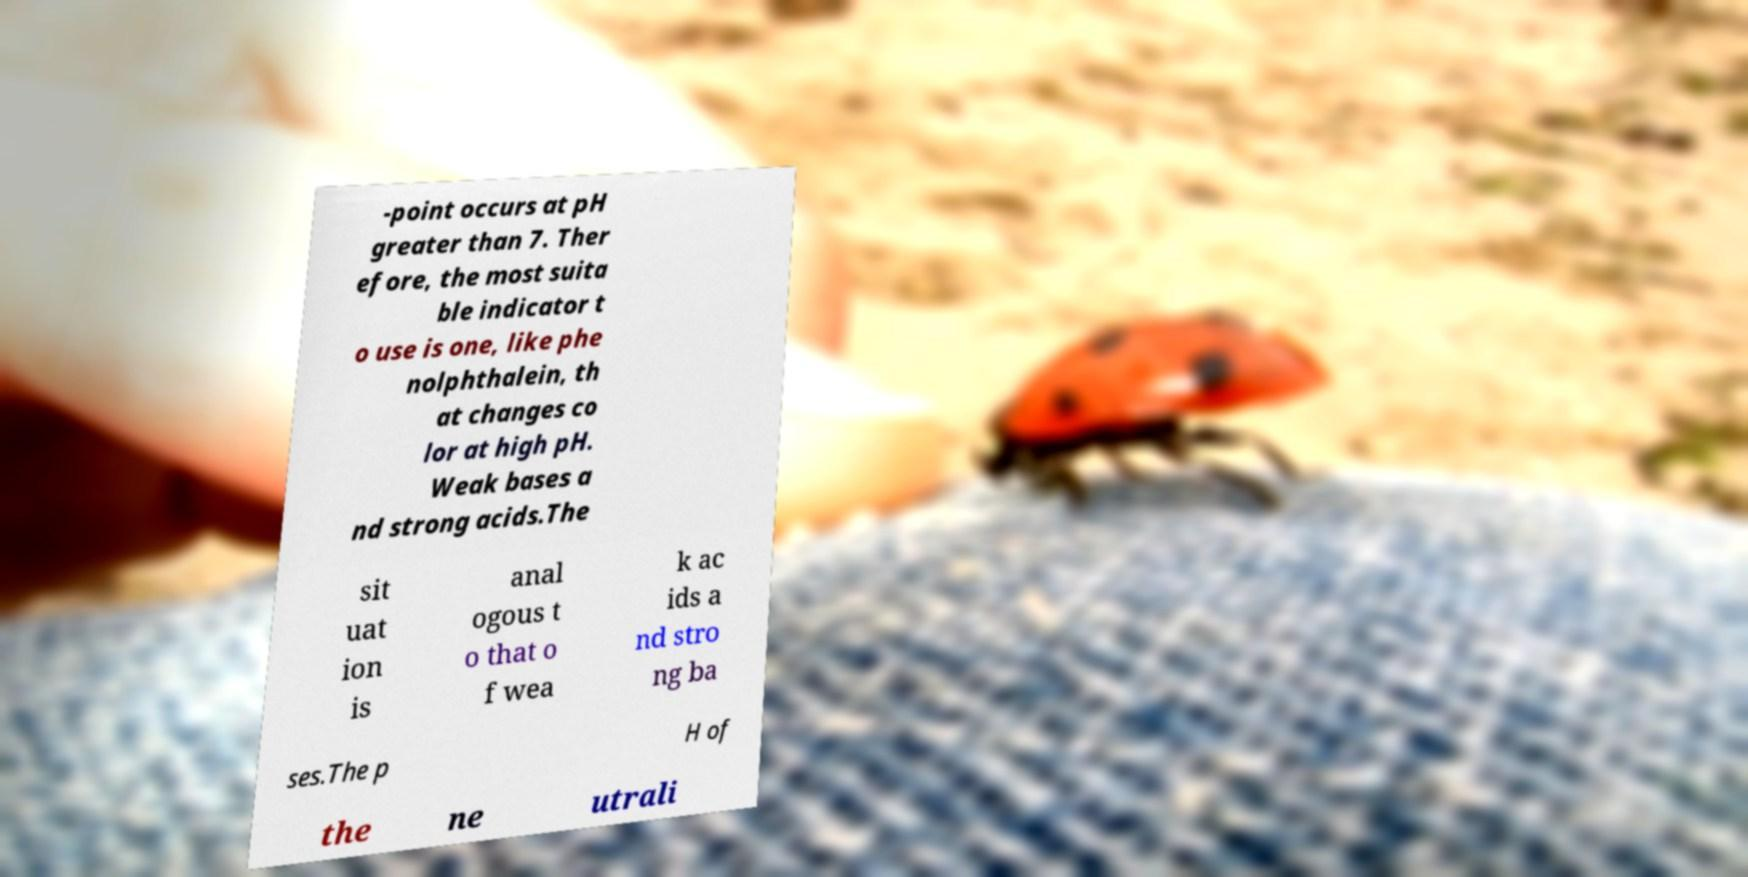Can you read and provide the text displayed in the image?This photo seems to have some interesting text. Can you extract and type it out for me? -point occurs at pH greater than 7. Ther efore, the most suita ble indicator t o use is one, like phe nolphthalein, th at changes co lor at high pH. Weak bases a nd strong acids.The sit uat ion is anal ogous t o that o f wea k ac ids a nd stro ng ba ses.The p H of the ne utrali 